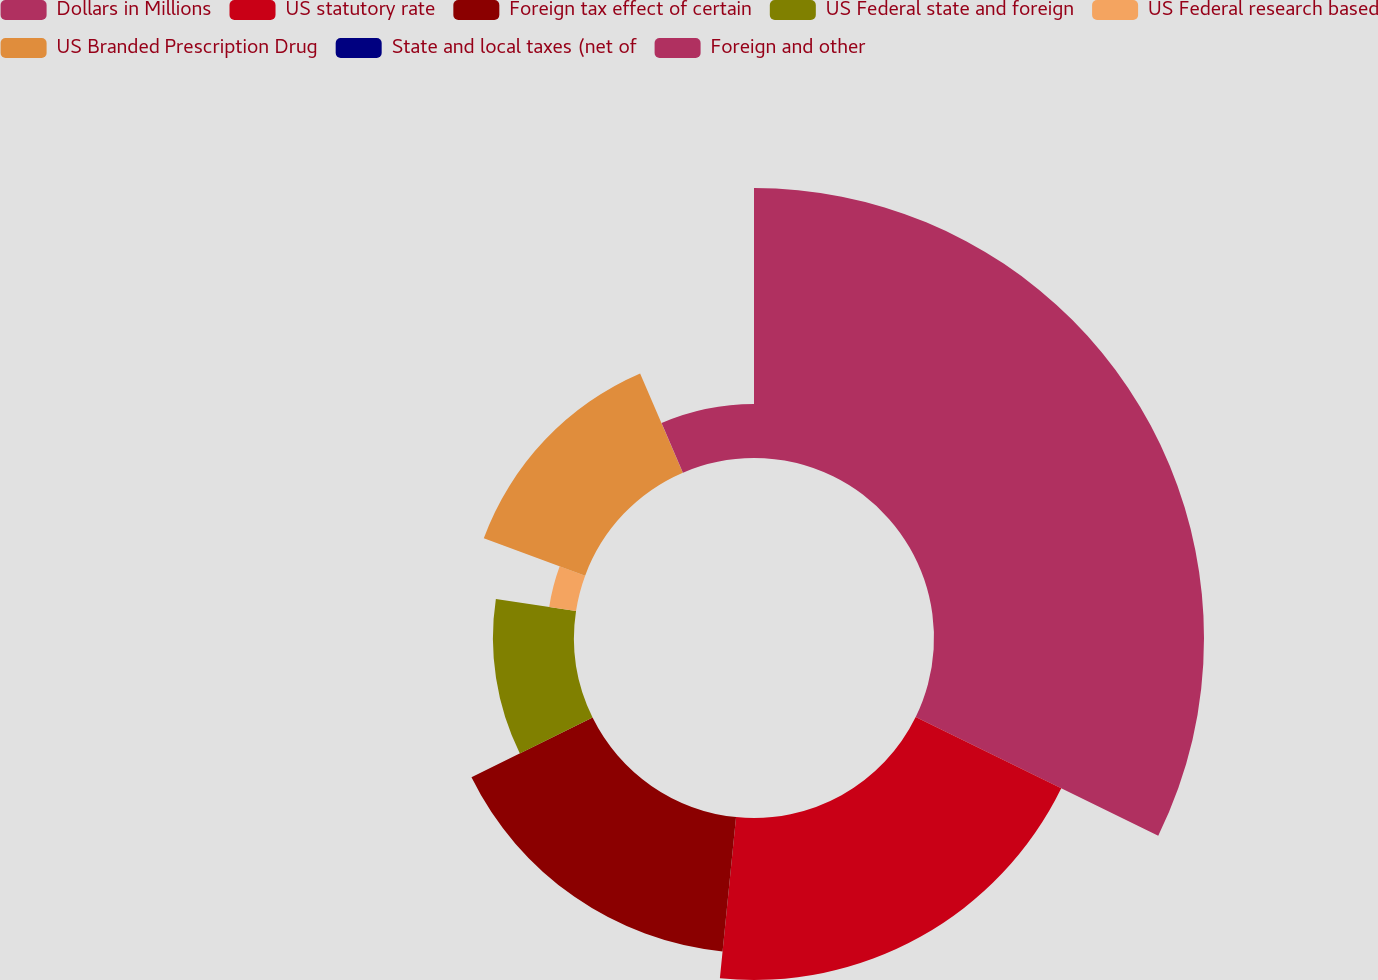Convert chart. <chart><loc_0><loc_0><loc_500><loc_500><pie_chart><fcel>Dollars in Millions<fcel>US statutory rate<fcel>Foreign tax effect of certain<fcel>US Federal state and foreign<fcel>US Federal research based<fcel>US Branded Prescription Drug<fcel>State and local taxes (net of<fcel>Foreign and other<nl><fcel>32.24%<fcel>19.35%<fcel>16.12%<fcel>9.68%<fcel>3.24%<fcel>12.9%<fcel>0.01%<fcel>6.46%<nl></chart> 